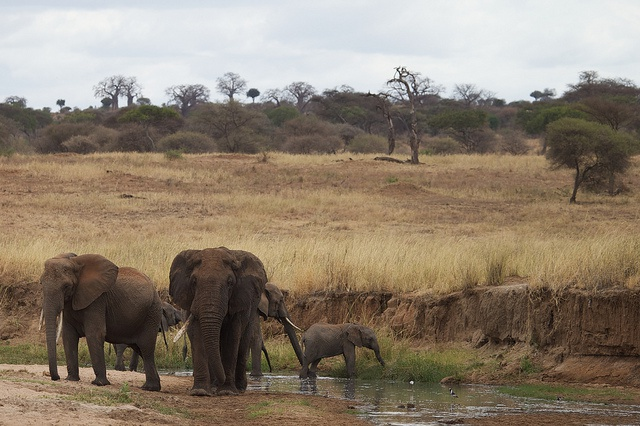Describe the objects in this image and their specific colors. I can see elephant in lightgray, black, maroon, and gray tones, elephant in lightgray, black, maroon, and gray tones, elephant in lightgray, black, and gray tones, elephant in lightgray, black, and gray tones, and elephant in lightgray, black, gray, and maroon tones in this image. 